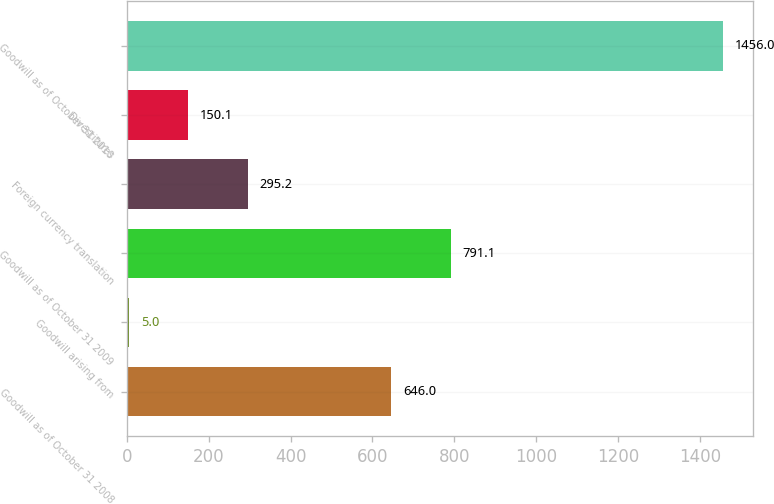Convert chart to OTSL. <chart><loc_0><loc_0><loc_500><loc_500><bar_chart><fcel>Goodwill as of October 31 2008<fcel>Goodwill arising from<fcel>Goodwill as of October 31 2009<fcel>Foreign currency translation<fcel>Divestitures<fcel>Goodwill as of October 31 2010<nl><fcel>646<fcel>5<fcel>791.1<fcel>295.2<fcel>150.1<fcel>1456<nl></chart> 